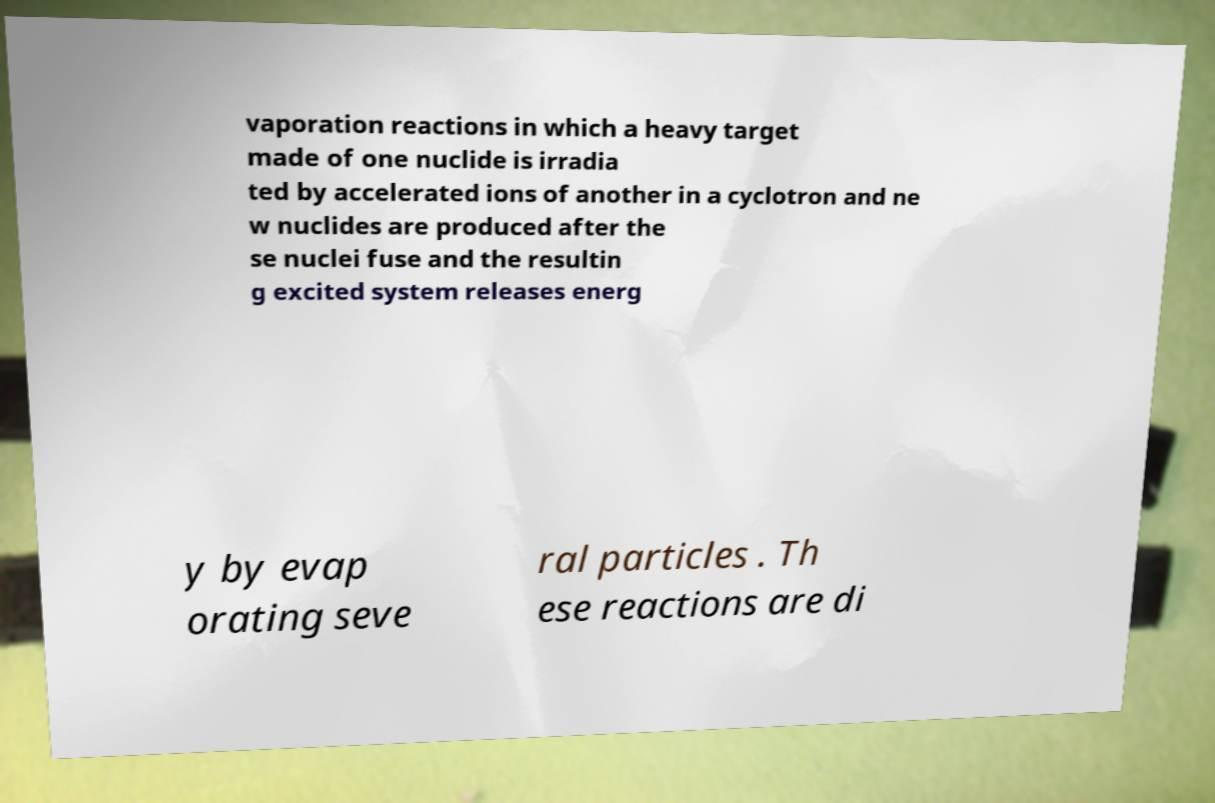Please read and relay the text visible in this image. What does it say? vaporation reactions in which a heavy target made of one nuclide is irradia ted by accelerated ions of another in a cyclotron and ne w nuclides are produced after the se nuclei fuse and the resultin g excited system releases energ y by evap orating seve ral particles . Th ese reactions are di 